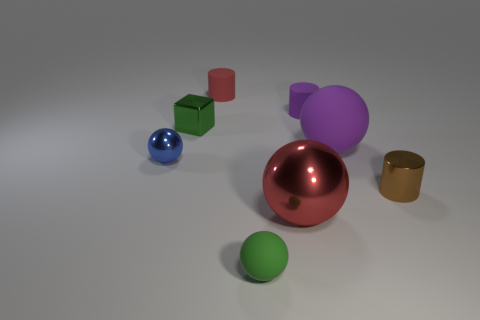Subtract all small green rubber spheres. How many spheres are left? 3 Subtract all red cylinders. How many cylinders are left? 2 Subtract all blue blocks. How many purple cylinders are left? 1 Add 1 large rubber things. How many objects exist? 9 Subtract 3 spheres. How many spheres are left? 1 Subtract all cylinders. How many objects are left? 5 Subtract all blue cylinders. Subtract all green blocks. How many cylinders are left? 3 Subtract all large gray metal spheres. Subtract all cubes. How many objects are left? 7 Add 8 big shiny things. How many big shiny things are left? 9 Add 3 big matte spheres. How many big matte spheres exist? 4 